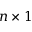<formula> <loc_0><loc_0><loc_500><loc_500>n \times 1</formula> 